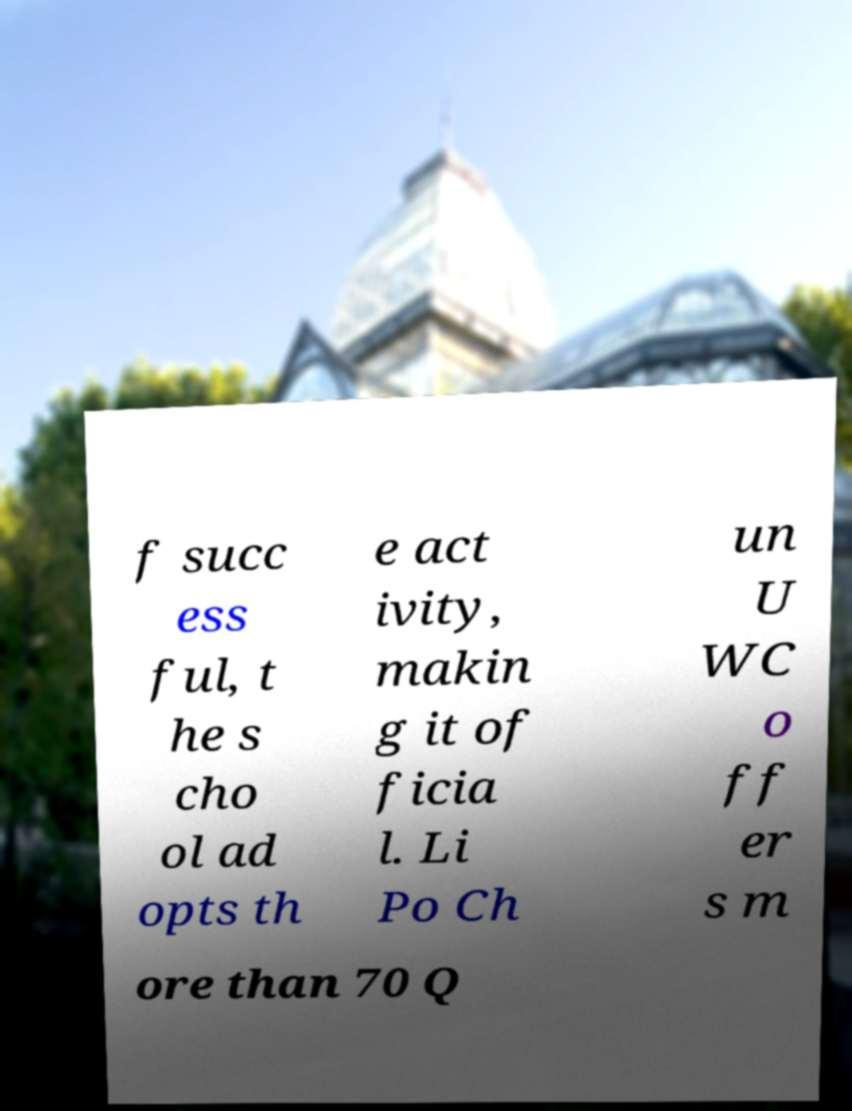What messages or text are displayed in this image? I need them in a readable, typed format. f succ ess ful, t he s cho ol ad opts th e act ivity, makin g it of ficia l. Li Po Ch un U WC o ff er s m ore than 70 Q 